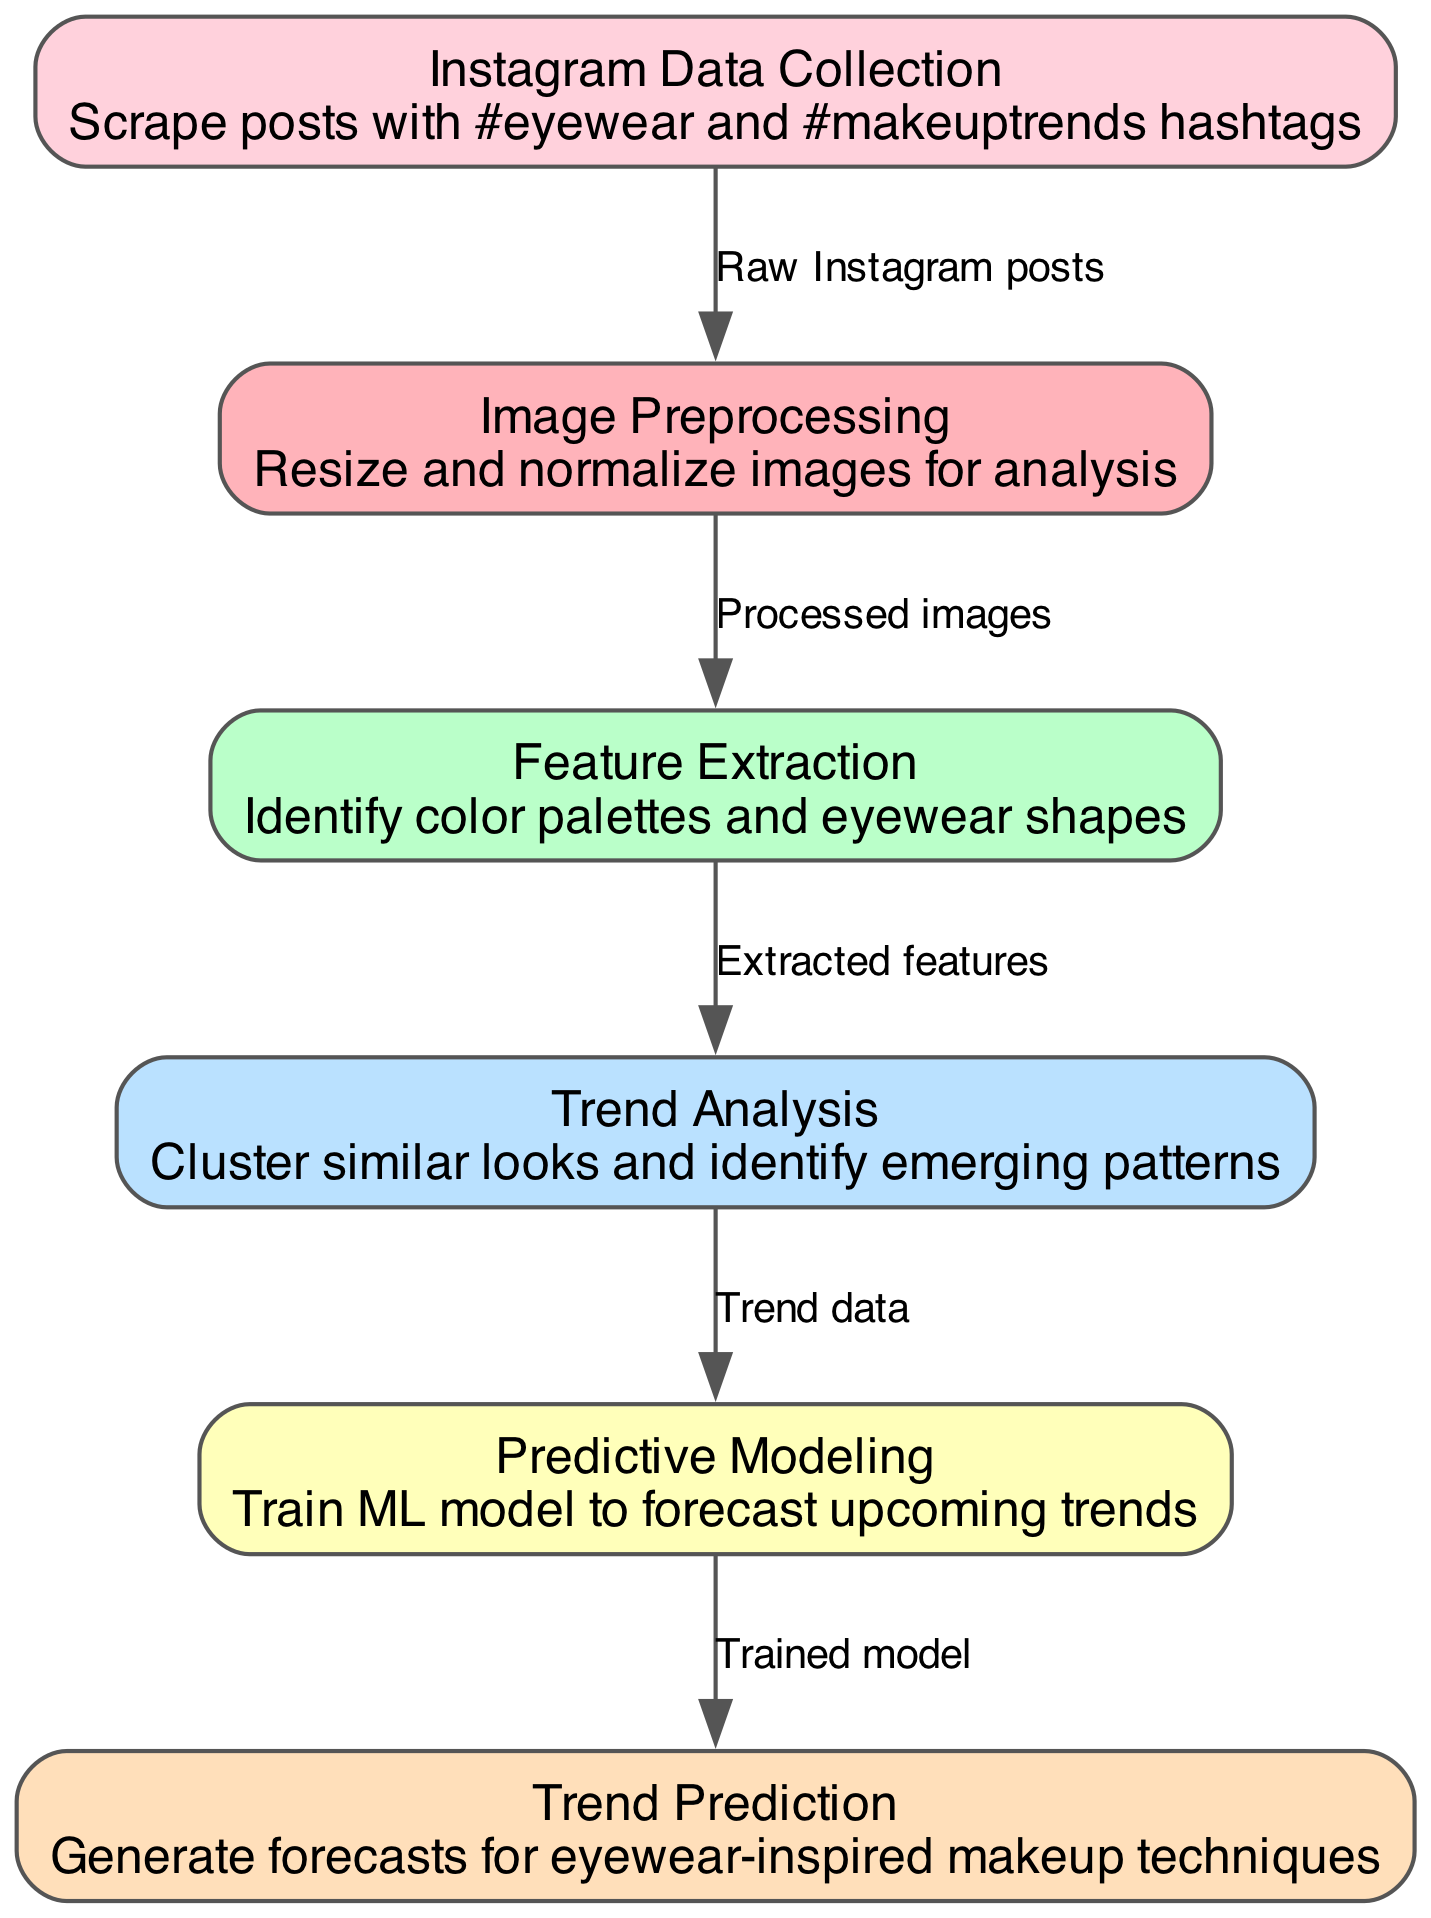What is the starting point of the pipeline? The first node in the diagram is "Instagram Data Collection," which indicates that the pipeline begins with collecting data from Instagram. This is confirmed by looking at the first node's position and description in the diagram.
Answer: Instagram Data Collection How many nodes are in the diagram? By counting the nodes listed in the data, we find there are six distinct nodes representing each step in the process. This includes all the individual processes shown in the diagram.
Answer: Six What process follows Image Preprocessing? The process that follows "Image Preprocessing" is "Feature Extraction." This is determined by examining the arrows connecting the nodes in the diagram, which indicates the flow from one process to the next.
Answer: Feature Extraction What type of data is passed from Trend Analysis to Predictive Modeling? The type of data passed is "Trend data." This is clear from the edge labeled transitioning from "Trend Analysis" to "Predictive Modeling," which summarizes what information is carried over.
Answer: Trend data How many edges connect the nodes in the diagram? Counting the edges shown in the edges list, we find five edges connecting the nodes, indicating the relationships and flow of information throughout the entire pipeline.
Answer: Five What is the final output of the pipeline? The final output of the pipeline is "Trend Prediction," which is the ultimate goal of the entire process as indicated by the last node in the flow of the diagram.
Answer: Trend Prediction Which step involves identifying emerging patterns? The step involving identifying emerging patterns is "Trend Analysis." This is evident from the node's description which specifically mentions clustering similar looks and discovering patterns from the data collected.
Answer: Trend Analysis Which process takes placed after Feature Extraction? The process that occurs after "Feature Extraction" is "Trend Analysis." By reviewing the connections between the nodes, this order of operations is straightforward to determine.
Answer: Trend Analysis What method is employed to forecast upcoming trends? The method employed to forecast upcoming trends is "Predictive Modeling." This indicates that a machine learning model is trained during this step to make predictions based on trends from the previous analysis.
Answer: Predictive Modeling 